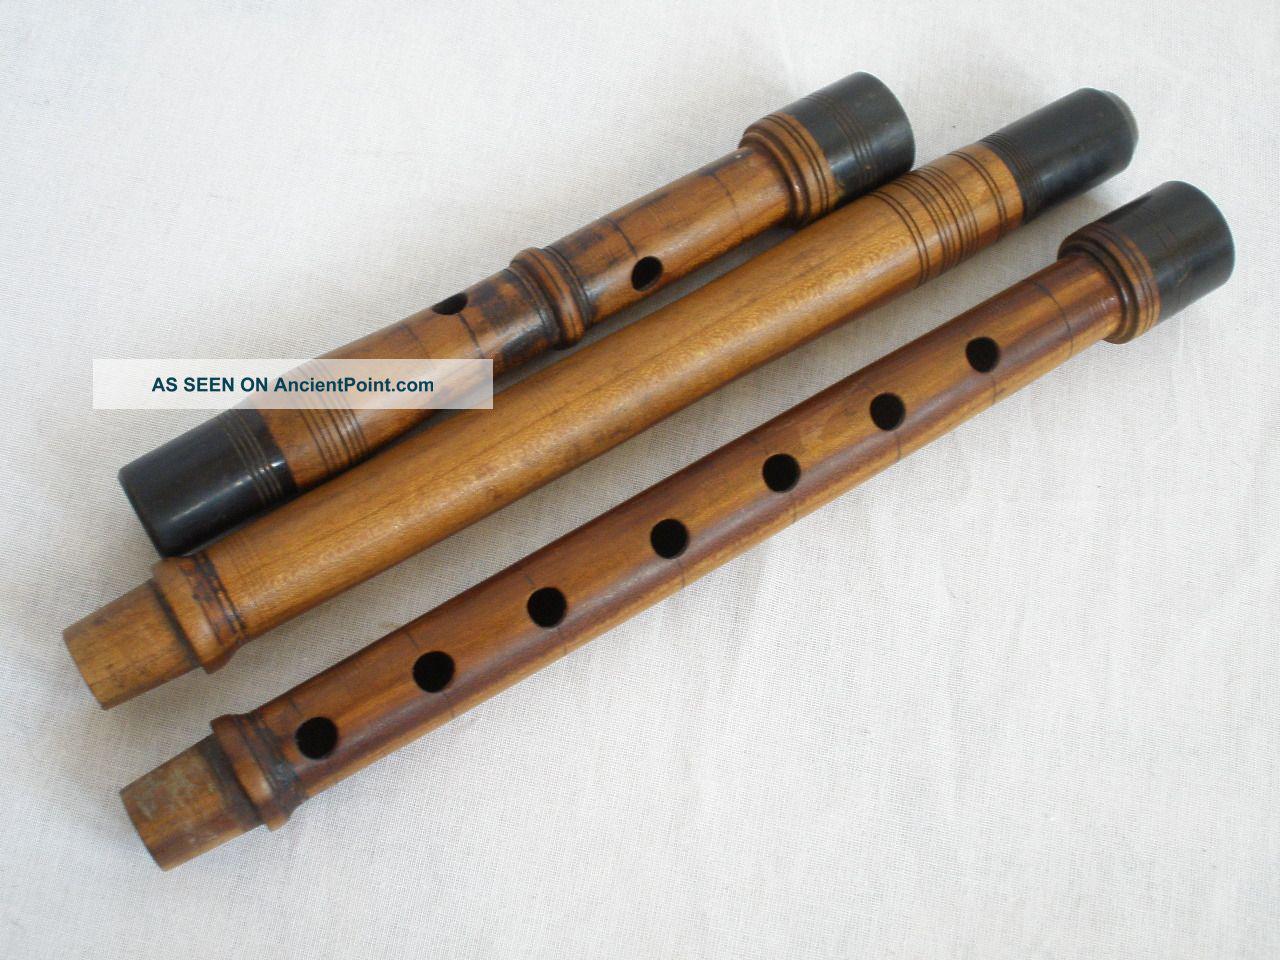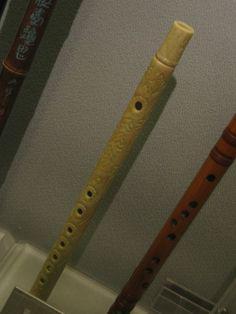The first image is the image on the left, the second image is the image on the right. Considering the images on both sides, is "The combined images contain exactly five flute-related objects." valid? Answer yes or no. Yes. The first image is the image on the left, the second image is the image on the right. Analyze the images presented: Is the assertion "There is exactly one flute in the right image." valid? Answer yes or no. No. 